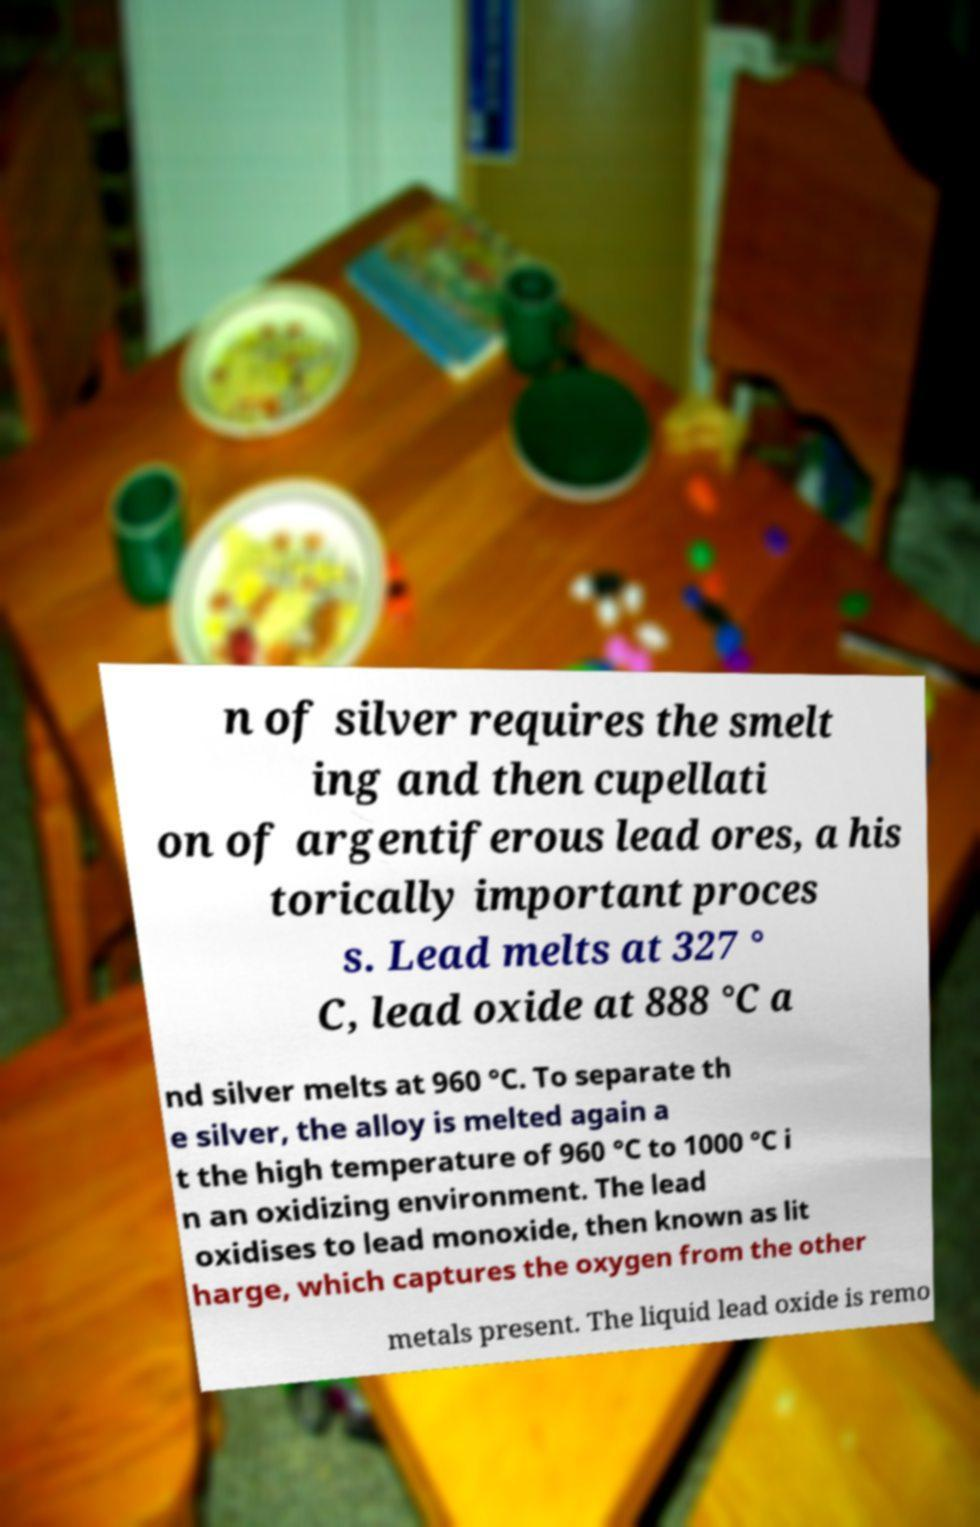Could you assist in decoding the text presented in this image and type it out clearly? n of silver requires the smelt ing and then cupellati on of argentiferous lead ores, a his torically important proces s. Lead melts at 327 ° C, lead oxide at 888 °C a nd silver melts at 960 °C. To separate th e silver, the alloy is melted again a t the high temperature of 960 °C to 1000 °C i n an oxidizing environment. The lead oxidises to lead monoxide, then known as lit harge, which captures the oxygen from the other metals present. The liquid lead oxide is remo 